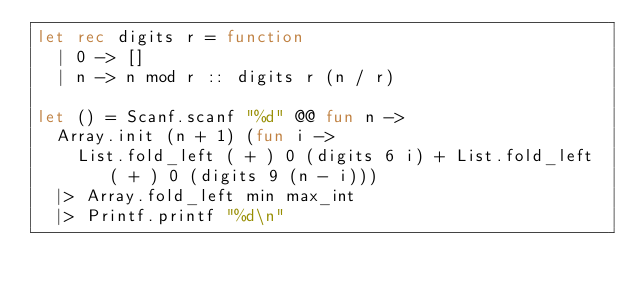<code> <loc_0><loc_0><loc_500><loc_500><_OCaml_>let rec digits r = function
  | 0 -> []
  | n -> n mod r :: digits r (n / r)
 
let () = Scanf.scanf "%d" @@ fun n ->
  Array.init (n + 1) (fun i ->
    List.fold_left ( + ) 0 (digits 6 i) + List.fold_left ( + ) 0 (digits 9 (n - i)))
  |> Array.fold_left min max_int
  |> Printf.printf "%d\n"</code> 